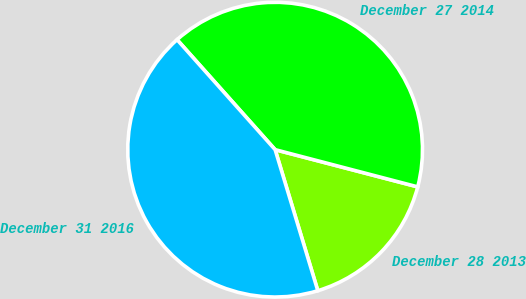Convert chart to OTSL. <chart><loc_0><loc_0><loc_500><loc_500><pie_chart><fcel>December 28 2013<fcel>December 27 2014<fcel>December 31 2016<nl><fcel>16.26%<fcel>40.65%<fcel>43.09%<nl></chart> 